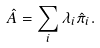<formula> <loc_0><loc_0><loc_500><loc_500>\hat { A } = \sum _ { i } \lambda _ { i } \hat { \pi } _ { i } .</formula> 